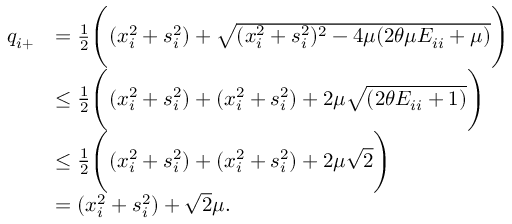Convert formula to latex. <formula><loc_0><loc_0><loc_500><loc_500>\begin{array} { r l } { q _ { i + } } & { = \frac { 1 } { 2 } \left ( ( x _ { i } ^ { 2 } + s _ { i } ^ { 2 } ) + \sqrt { ( x _ { i } ^ { 2 } + s _ { i } ^ { 2 } ) ^ { 2 } - 4 \mu ( 2 \theta \mu E _ { i i } + \mu ) } \right ) } \\ & { \leq \frac { 1 } { 2 } \left ( ( x _ { i } ^ { 2 } + s _ { i } ^ { 2 } ) + ( x _ { i } ^ { 2 } + s _ { i } ^ { 2 } ) + 2 \mu \sqrt { ( 2 \theta E _ { i i } + 1 ) } \right ) } \\ & { \leq \frac { 1 } { 2 } \left ( ( x _ { i } ^ { 2 } + s _ { i } ^ { 2 } ) + ( x _ { i } ^ { 2 } + s _ { i } ^ { 2 } ) + 2 \mu \sqrt { 2 } \right ) } \\ & { = ( x _ { i } ^ { 2 } + s _ { i } ^ { 2 } ) + \sqrt { 2 } \mu . } \end{array}</formula> 